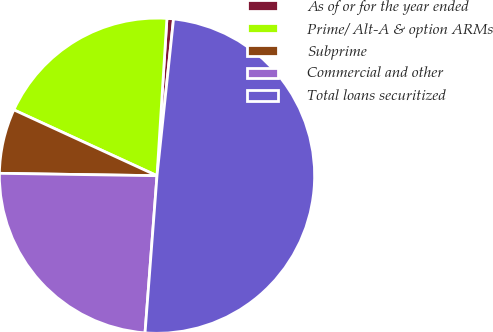<chart> <loc_0><loc_0><loc_500><loc_500><pie_chart><fcel>As of or for the year ended<fcel>Prime/ Alt-A & option ARMs<fcel>Subprime<fcel>Commercial and other<fcel>Total loans securitized<nl><fcel>0.67%<fcel>19.14%<fcel>6.62%<fcel>24.03%<fcel>49.54%<nl></chart> 